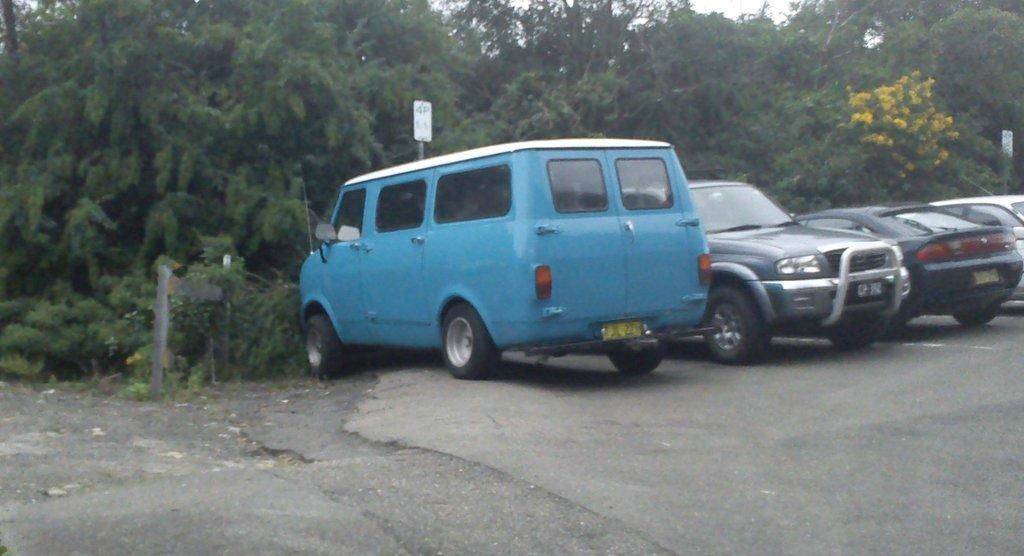Can you describe this image briefly? In this image, we can see few vehicles are parked on the road. Background we can see so many trees, flowers, boards with poles. 